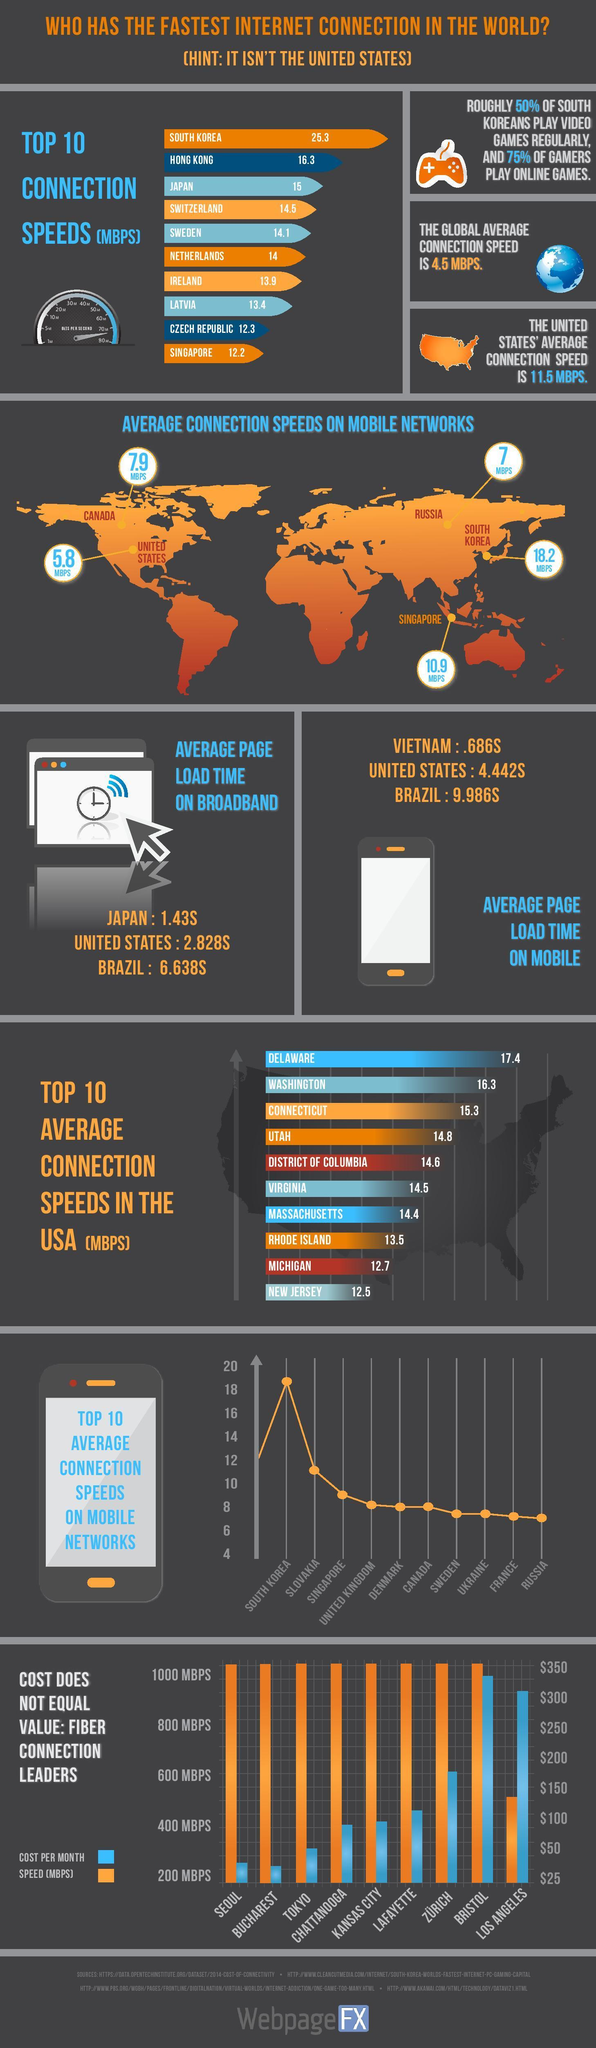Which three cities have internet connection that costs below $50 per month?
Answer the question with a short phrase. SEOUL, BUCHAREST, TOKYO By what mbps is the connection speed in the United States higher than the global average speed? 7 As per the bar chart, which city has the lowest connection speed but high cost per month? LOS ANGELES What is the difference in global average connection speed and the country with highest sppe? 20.8 MBPS Which state has the third highest speed in the USA? CONNECTICUT Which city has 1000 MBPS internet that costs above $300 as per the bar chart? BRISTOL Which country has the lowest average connection speeds on mobile network as shown in the map? SOUTH KOREA By how much is Japan's average page load time faster than the US? 1.398S 